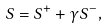Convert formula to latex. <formula><loc_0><loc_0><loc_500><loc_500>S = S ^ { + } + \gamma S ^ { - } ,</formula> 